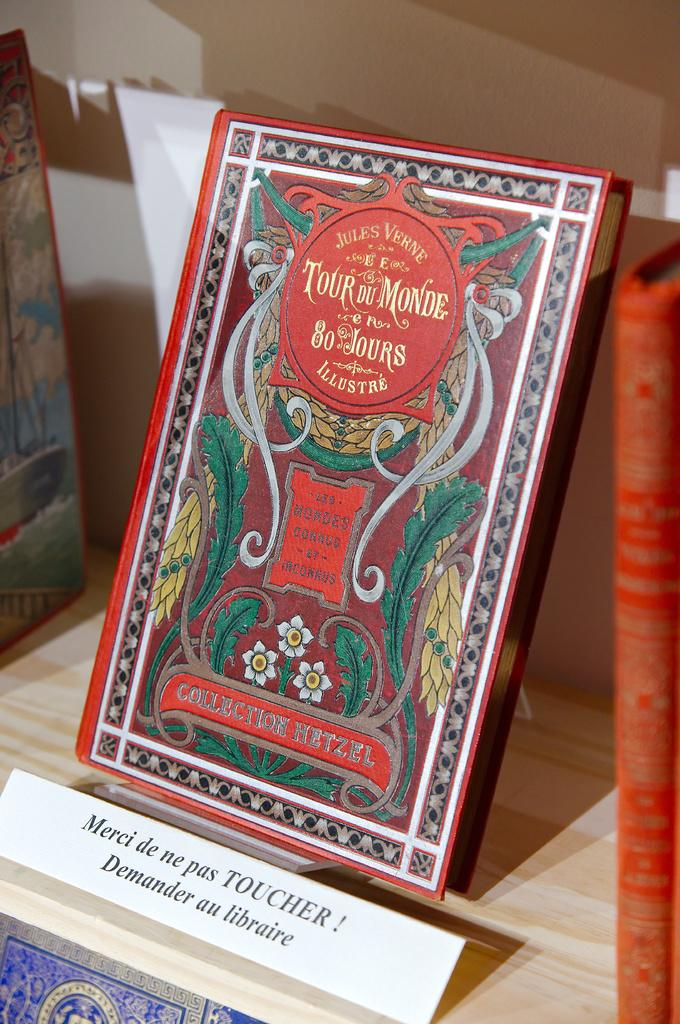Provide a one-sentence caption for the provided image. A red book with green feathers on the cover is labeled as Collection Hetzel. 